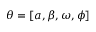Convert formula to latex. <formula><loc_0><loc_0><loc_500><loc_500>\theta = [ a , \beta , \omega , \phi ]</formula> 